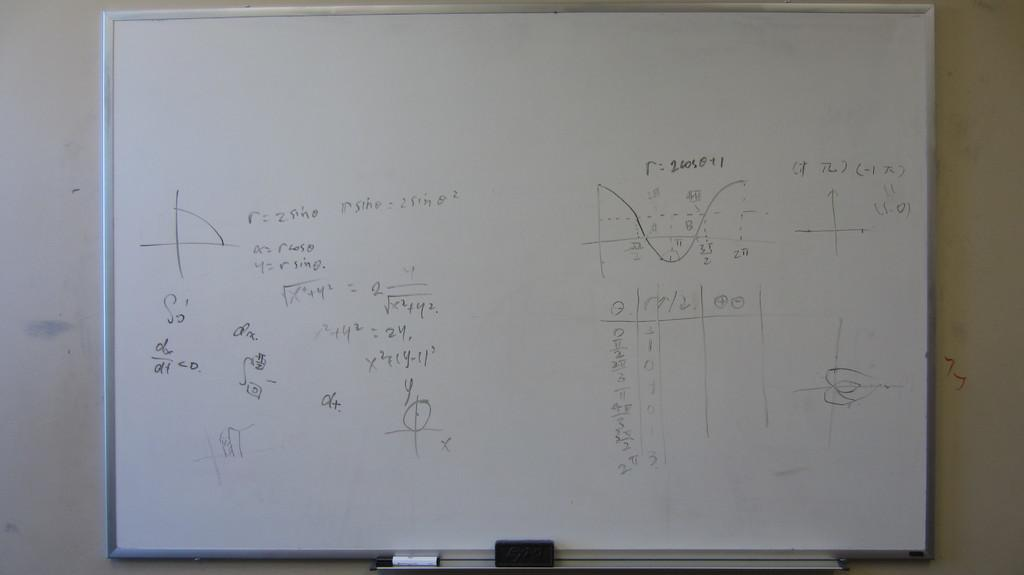Provide a one-sentence caption for the provided image. A whiteboard with mathematical graphs and equation such as "r = 2 sin θ". 